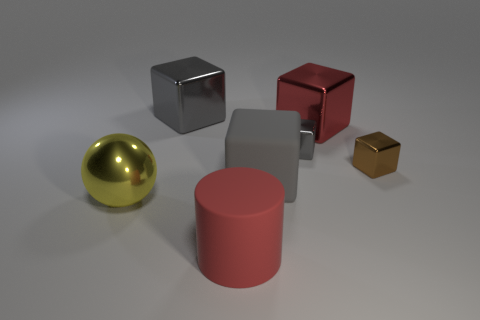How many gray cubes must be subtracted to get 1 gray cubes? 2 Subtract all yellow balls. How many gray blocks are left? 3 Subtract all red metal cubes. How many cubes are left? 4 Subtract 3 cubes. How many cubes are left? 2 Subtract all brown cubes. How many cubes are left? 4 Add 2 large cyan cylinders. How many objects exist? 9 Subtract all blocks. How many objects are left? 2 Add 1 red matte cylinders. How many red matte cylinders are left? 2 Add 3 gray matte blocks. How many gray matte blocks exist? 4 Subtract 1 red cylinders. How many objects are left? 6 